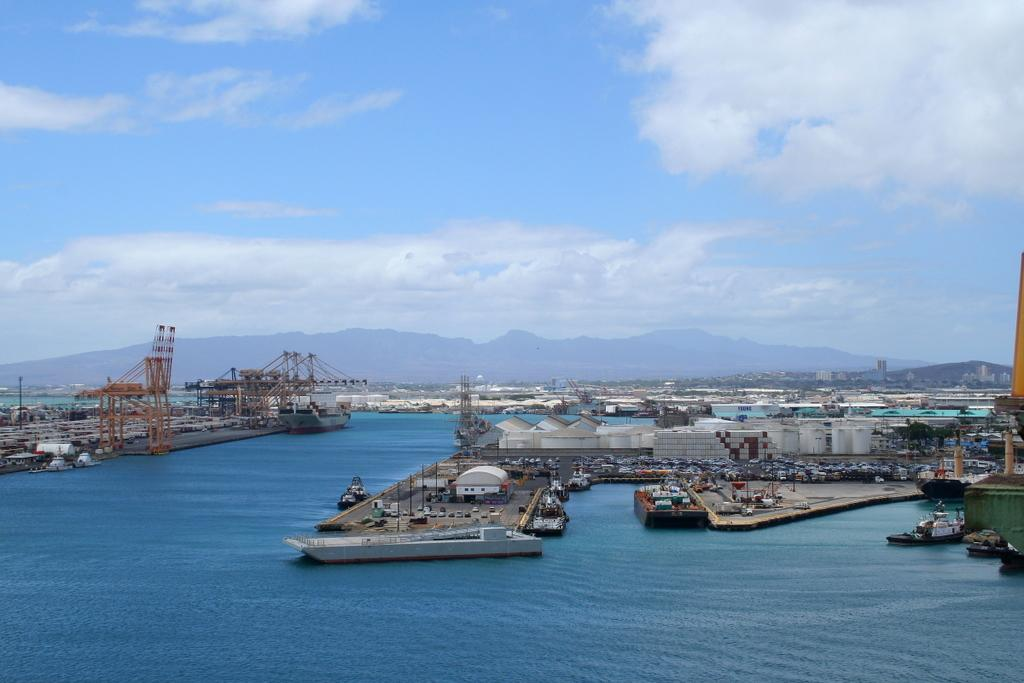What is the primary element visible in the image? There is water in the image. What types of vehicles can be seen in the image? There are vehicles, boats, and ships in the image. What structures are present in the image? There are towers, poles, pillars, and buildings in the image. What is visible in the background of the image? There is a mountain and sky visible in the background of the image. What can be seen in the sky? There are clouds in the sky. What type of wren can be seen perched on the pole in the image? There is no wren present in the image; the poles are not associated with any birds. What holiday is being celebrated in the image? There is no indication of a holiday being celebrated in the image. 